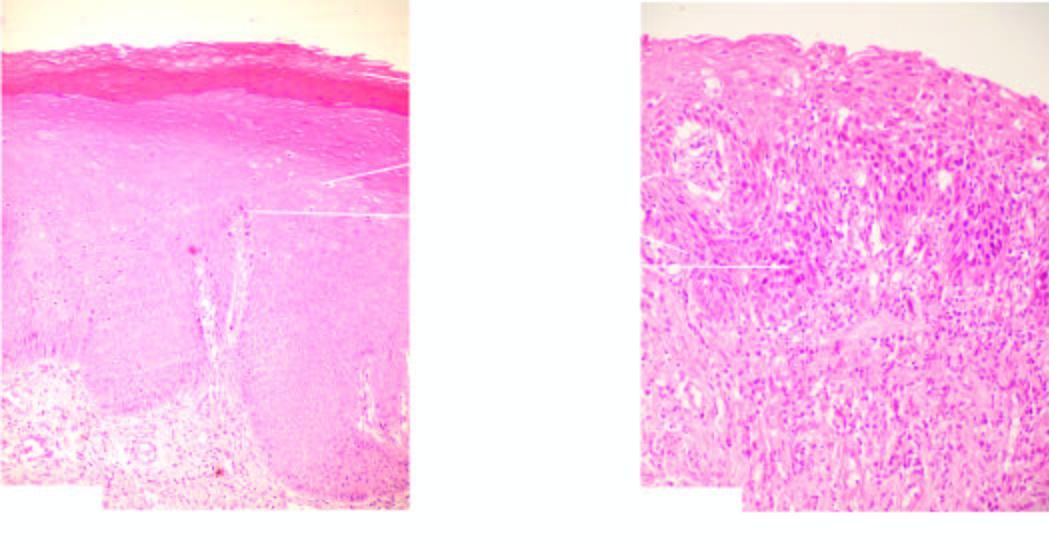what show features of cytologic atypia and mitosis?
Answer the question using a single word or phrase. Individual cells in layers 